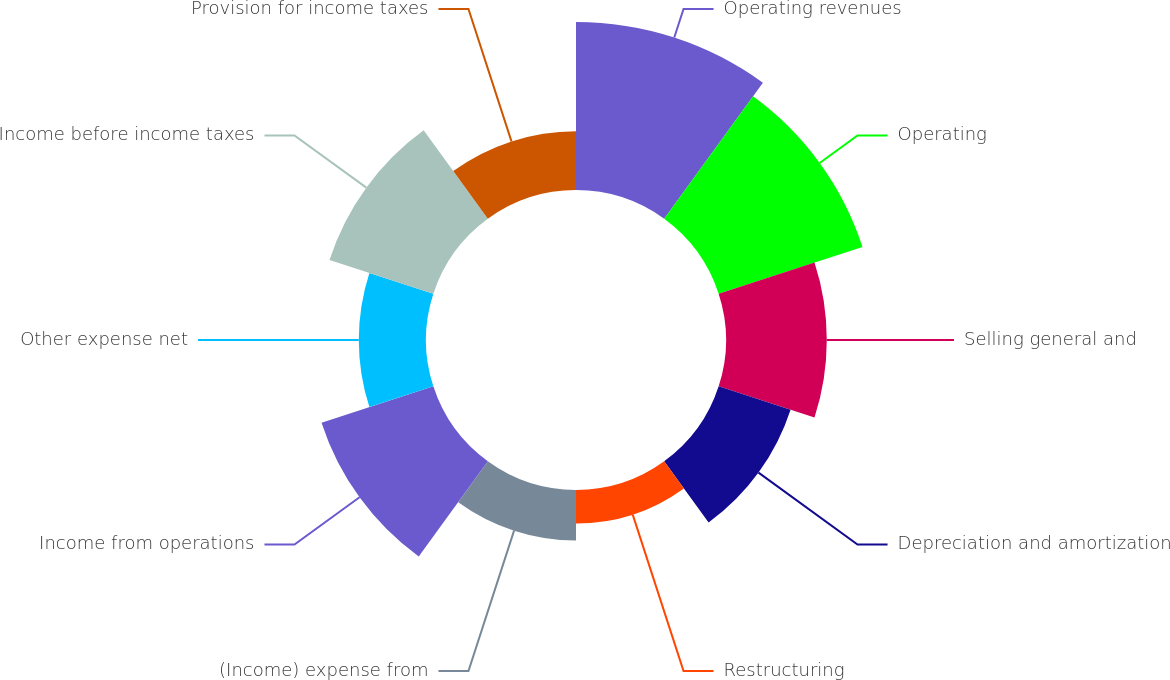Convert chart to OTSL. <chart><loc_0><loc_0><loc_500><loc_500><pie_chart><fcel>Operating revenues<fcel>Operating<fcel>Selling general and<fcel>Depreciation and amortization<fcel>Restructuring<fcel>(Income) expense from<fcel>Income from operations<fcel>Other expense net<fcel>Income before income taxes<fcel>Provision for income taxes<nl><fcel>18.02%<fcel>16.22%<fcel>10.81%<fcel>8.11%<fcel>3.6%<fcel>5.41%<fcel>12.61%<fcel>7.21%<fcel>11.71%<fcel>6.31%<nl></chart> 